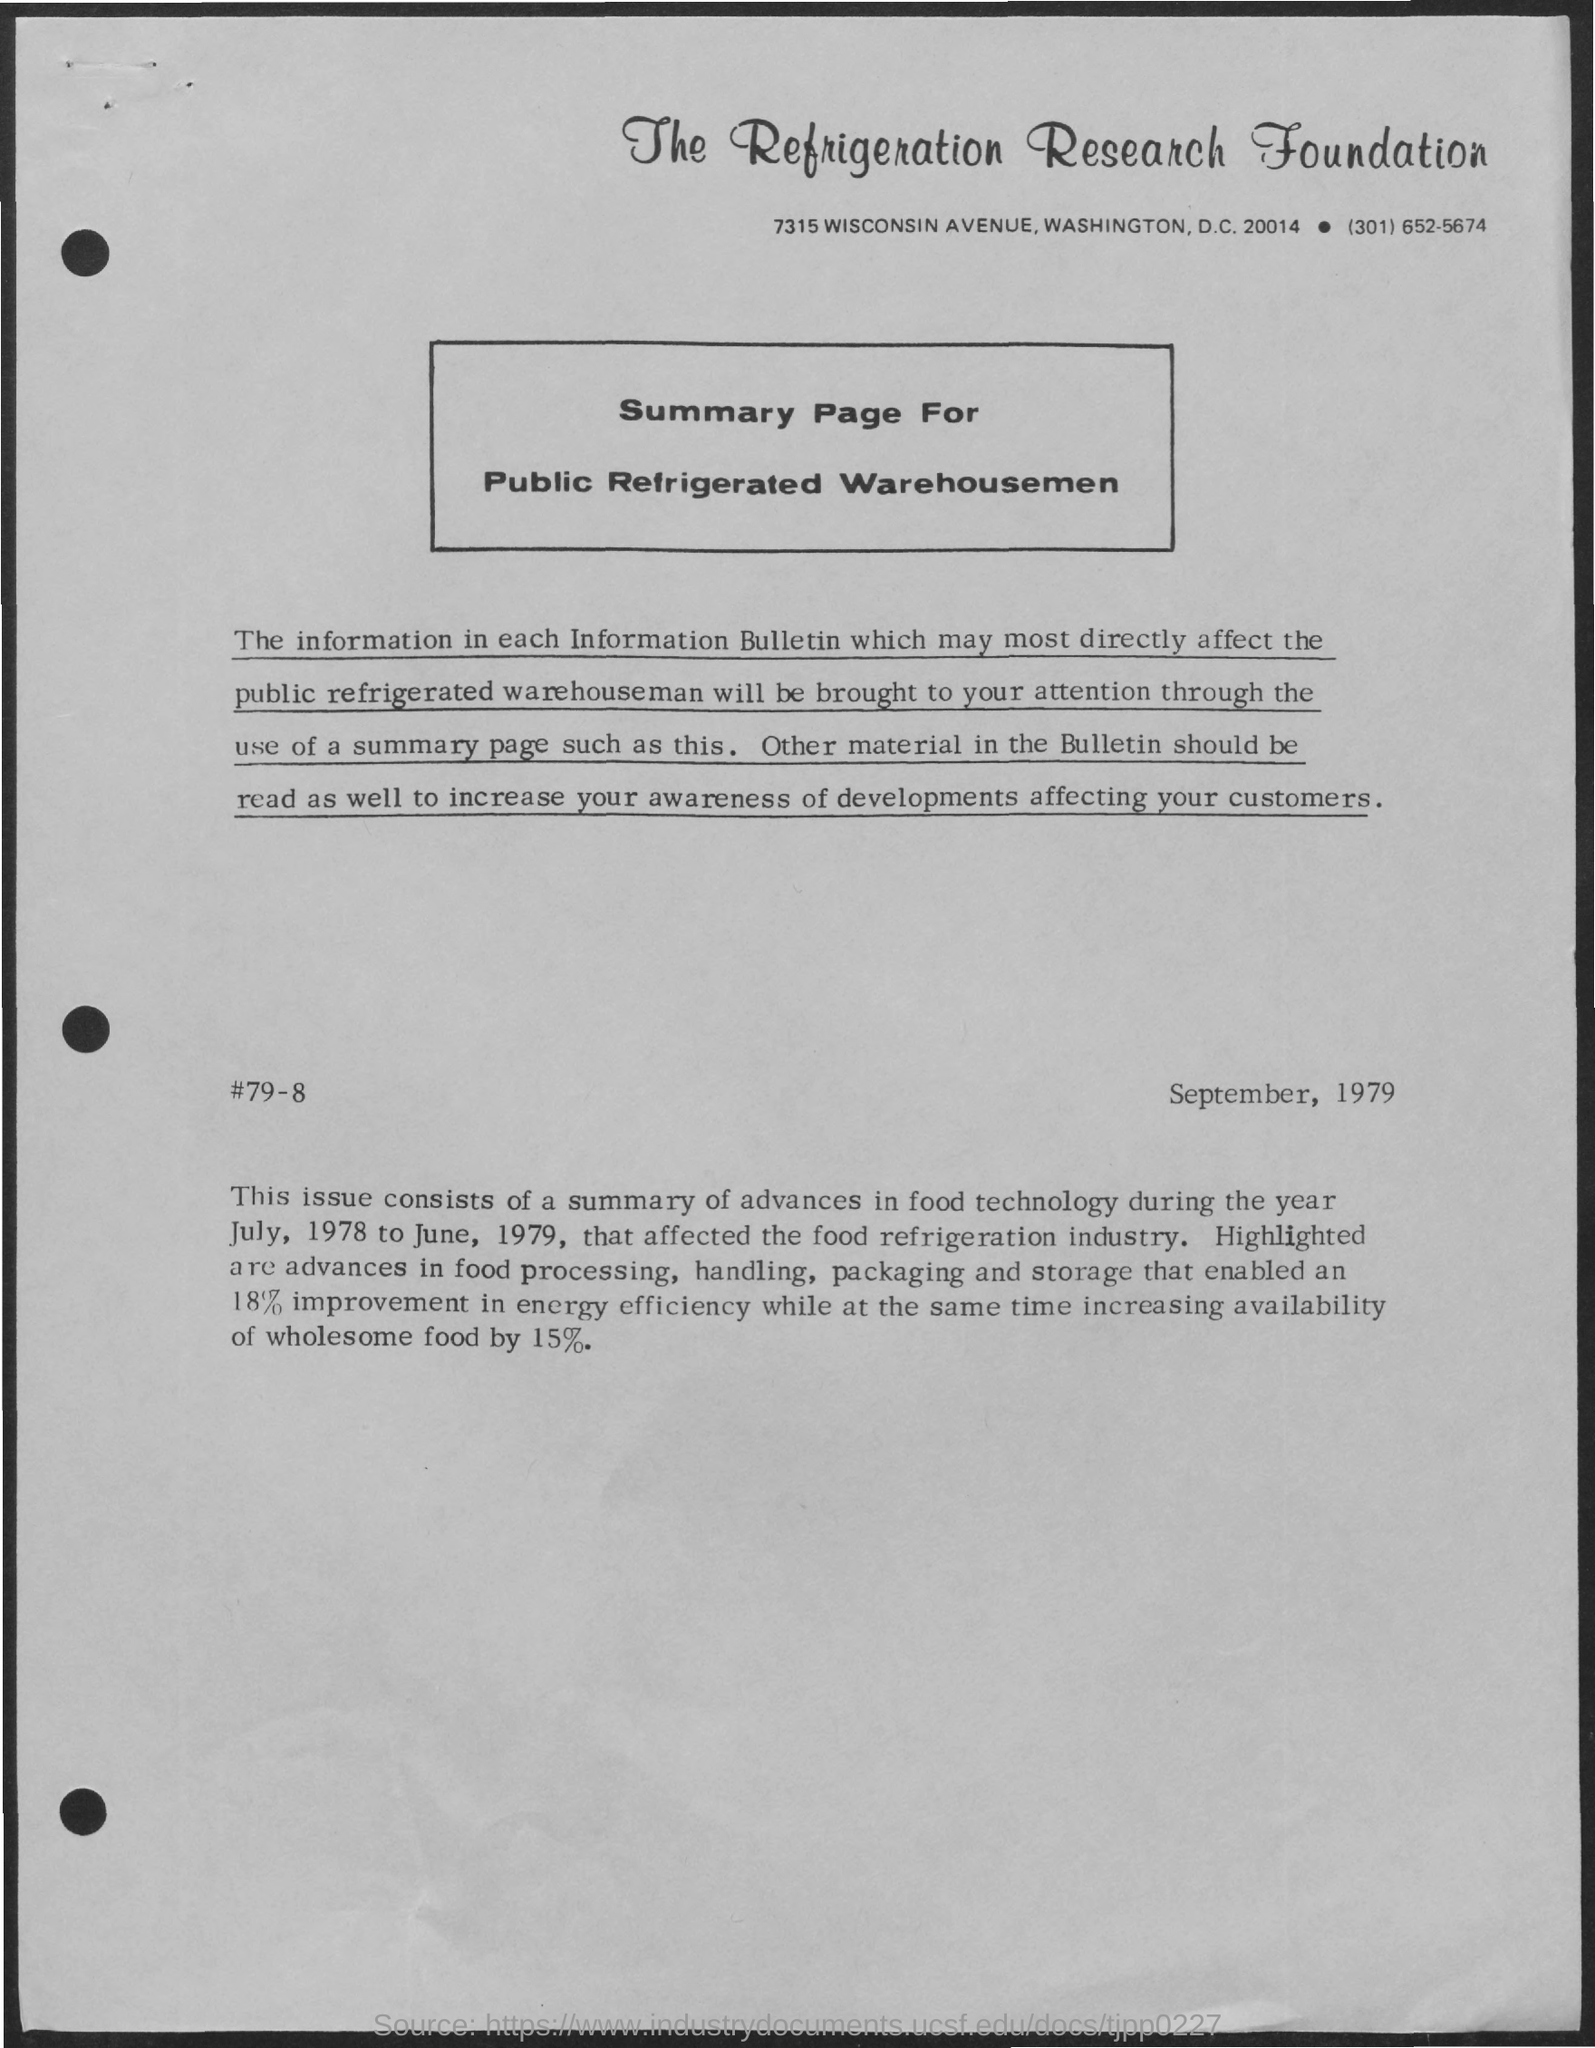Specify some key components in this picture. The title of the document is [The Refrigeration Research Foundation]. 